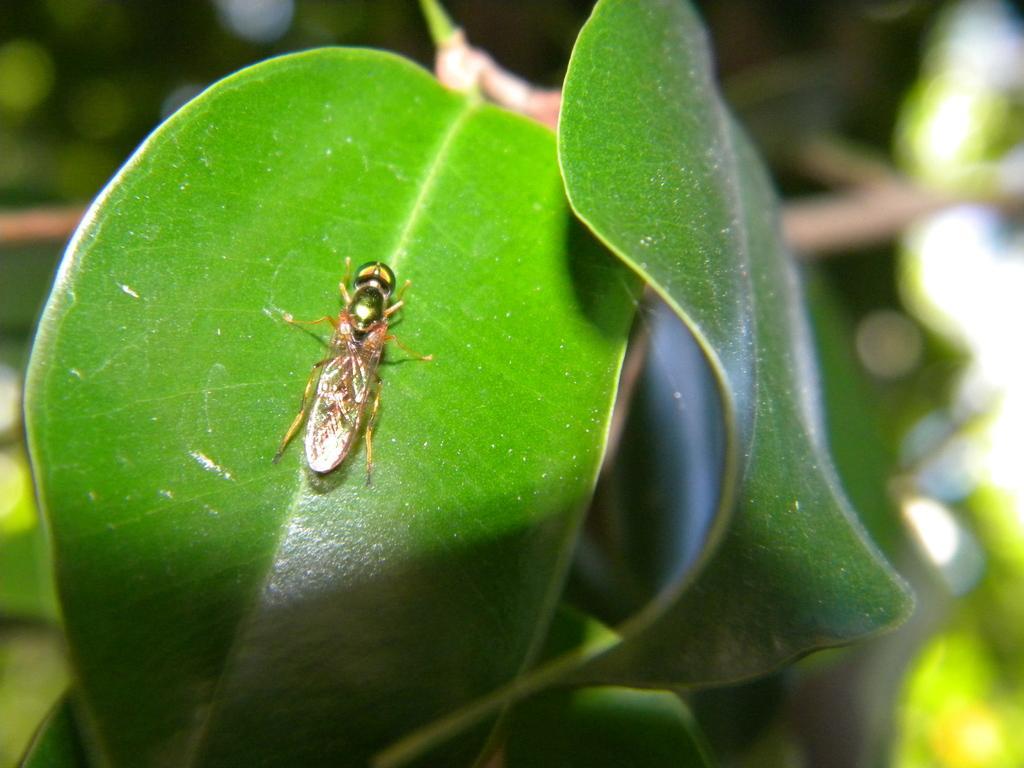How would you summarize this image in a sentence or two? In this image I can see two leaves which are green in color and on the leaf I can see an insect. I can see the blurry background. 